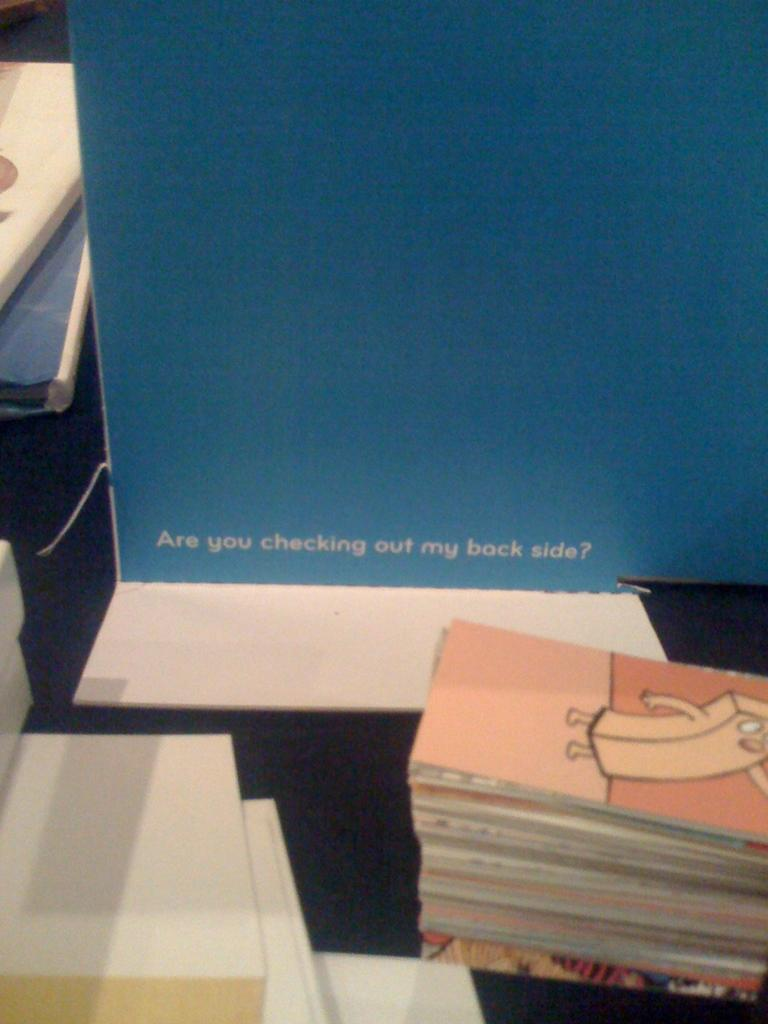<image>
Relay a brief, clear account of the picture shown. A table display includes a sign which asks if someone's backside is being checked out. 